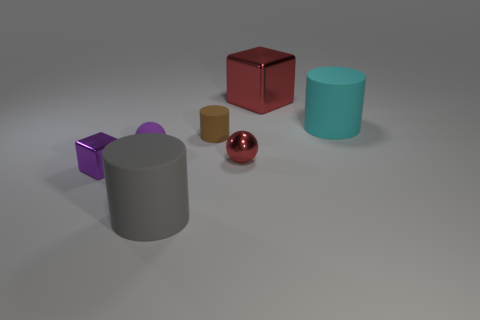What number of cyan things have the same size as the brown cylinder?
Provide a succinct answer. 0. There is a cube in front of the tiny purple matte thing; is its color the same as the big object in front of the big cyan matte object?
Make the answer very short. No. There is a big cyan matte object; are there any large gray things behind it?
Offer a very short reply. No. The shiny object that is both to the right of the tiny matte cylinder and to the left of the large red shiny object is what color?
Keep it short and to the point. Red. Are there any other small shiny blocks that have the same color as the small metallic cube?
Offer a terse response. No. Are the thing that is behind the cyan rubber thing and the cylinder that is on the left side of the brown matte object made of the same material?
Provide a short and direct response. No. There is a red object that is behind the red metal ball; what is its size?
Give a very brief answer. Large. What size is the purple block?
Your answer should be very brief. Small. What size is the red metal object in front of the big rubber thing that is to the right of the big thing in front of the cyan object?
Ensure brevity in your answer.  Small. Is there a large brown block made of the same material as the big cyan thing?
Provide a short and direct response. No. 